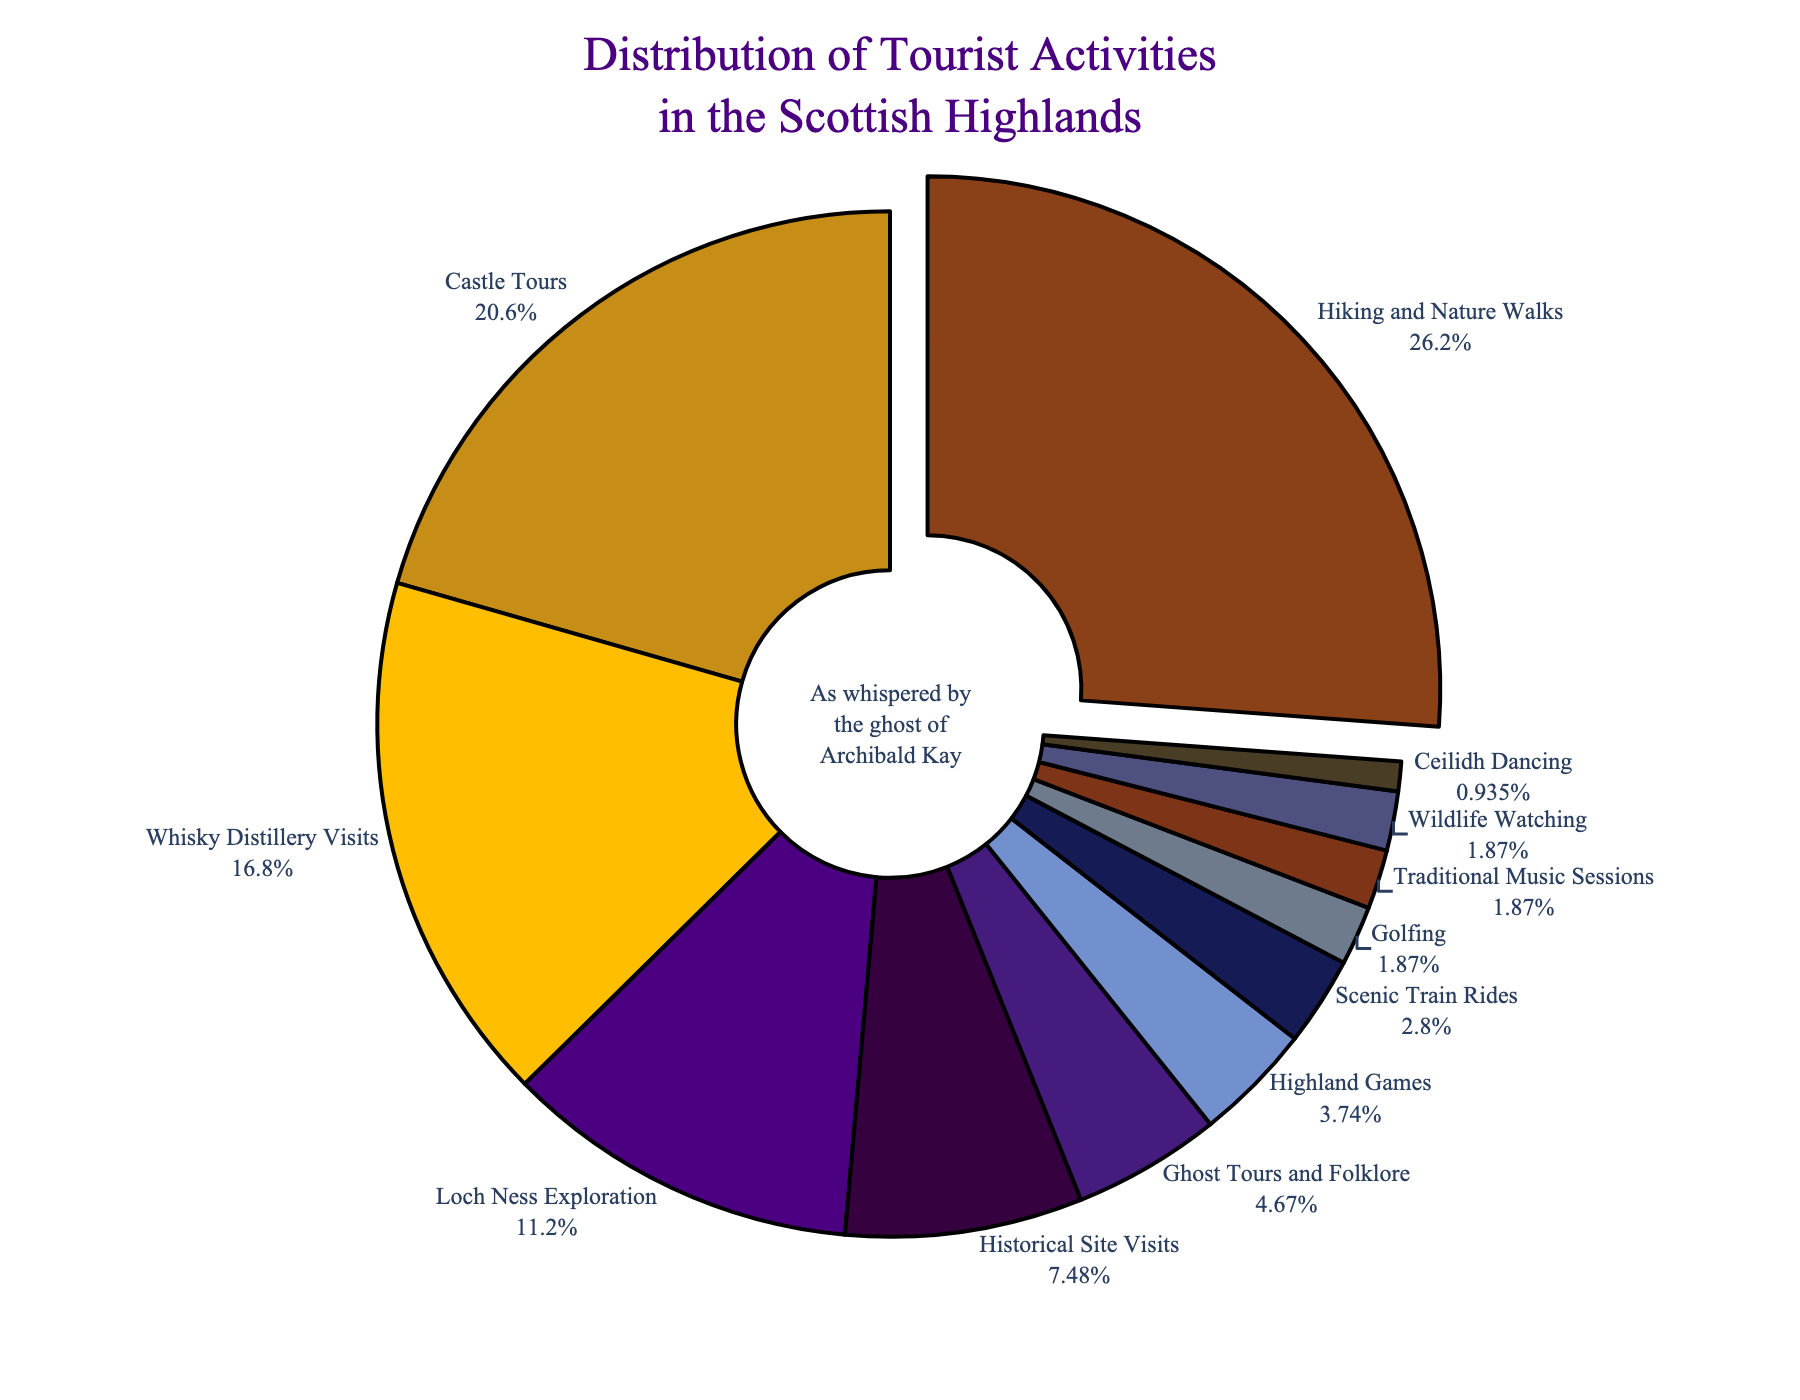What's the most common tourist activity? Look for the largest section in the pie chart. The largest section is labeled "Hiking and Nature Walks" with 28%.
Answer: Hiking and Nature Walks How much higher is the percentage of Castle Tours compared to Ghost Tours and Folklore? Find the percentages of Castle Tours (22%) and Ghost Tours and Folklore (5%). Calculate the difference: 22% - 5% = 17%.
Answer: 17% Which activities occupy less than 5% of the total? Identify sections with percentages less than 5%: Highland Games (4%), Scenic Train Rides (3%), Golfing (2%), Traditional Music Sessions (2%), Wildlife Watching (2%), Ceilidh Dancing (1%).
Answer: Highland Games, Scenic Train Rides, Golfing, Traditional Music Sessions, Wildlife Watching, Ceilidh Dancing What is the combined percentage of Historical Site Visits and Ghost Tours and Folklore? Find the percentages of Historical Site Visits (8%) and Ghost Tours and Folklore (5%). Sum them: 8% + 5% = 13%.
Answer: 13% Which activity has the smallest percentage? Look for the smallest section in the pie chart. It is labeled "Ceilidh Dancing" with 1%.
Answer: Ceilidh Dancing How does the percentage of Whisky Distillery Visits compare to that of Loch Ness Exploration? Find the percentages of Whisky Distillery Visits (18%) and Loch Ness Exploration (12%). Whisky Distillery Visits have a higher percentage by 6% (18% - 12%).
Answer: Whisky Distillery Visits have 6% more What is the total percentage of the activities labeled with both blue and purple shades? Identify sections labeled with colors defined as blue or purple: Whisky Distillery Visits (18%), Ghost Tours and Folklore (5%), Scenic Train Rides (3%), Historical Site Visits (8%). Sum them up: 18% + 5% + 3% + 8% = 34%.
Answer: 34% Which activity is visually emphasized in the pie chart and why? The portion labeled "Hiking and Nature Walks" is pulled out slightly from the pie chart, indicating it is visually emphasized. It is the activity with the highest percentage (28%).
Answer: Hiking and Nature Walks; it has the highest percentage What's the difference in percentage between the most and least popular activities? Identify the percentages of the most popular activity (Hiking and Nature Walks, 28%) and the least popular activity (Ceilidh Dancing, 1%). Subtract the latter from the former: 28% - 1% = 27%.
Answer: 27% 